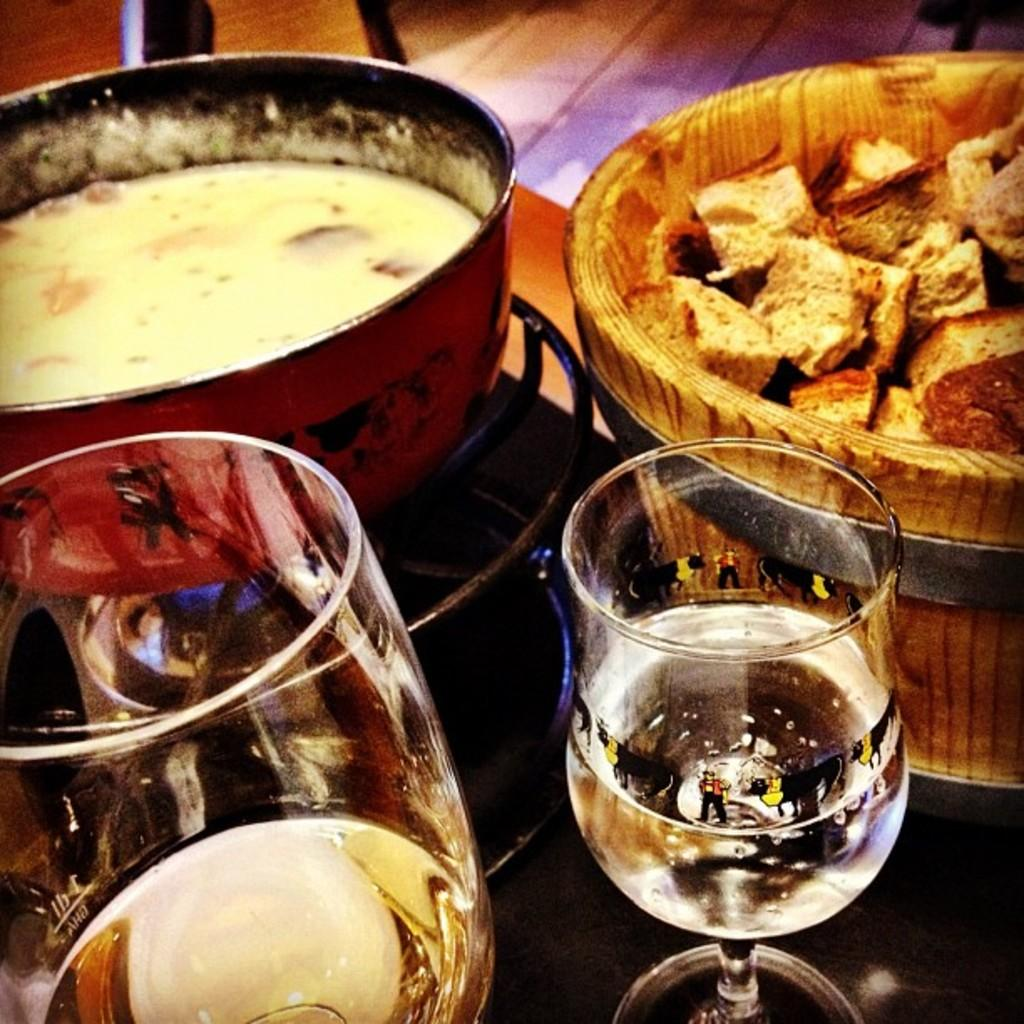What can be seen in the bowls in the image? There are bowls with food in the image. What else is present on the table in the image? There are glasses in the image. Where is the scene in the image taking place? The image appears to be set on a table. Can you tell me how many tigers are sitting at the table in the image? There are no tigers present in the image; it features bowls with food and glasses on a table. What type of lunch is being served in the image? The image does not specify the type of food being served; it only shows bowls with food. 